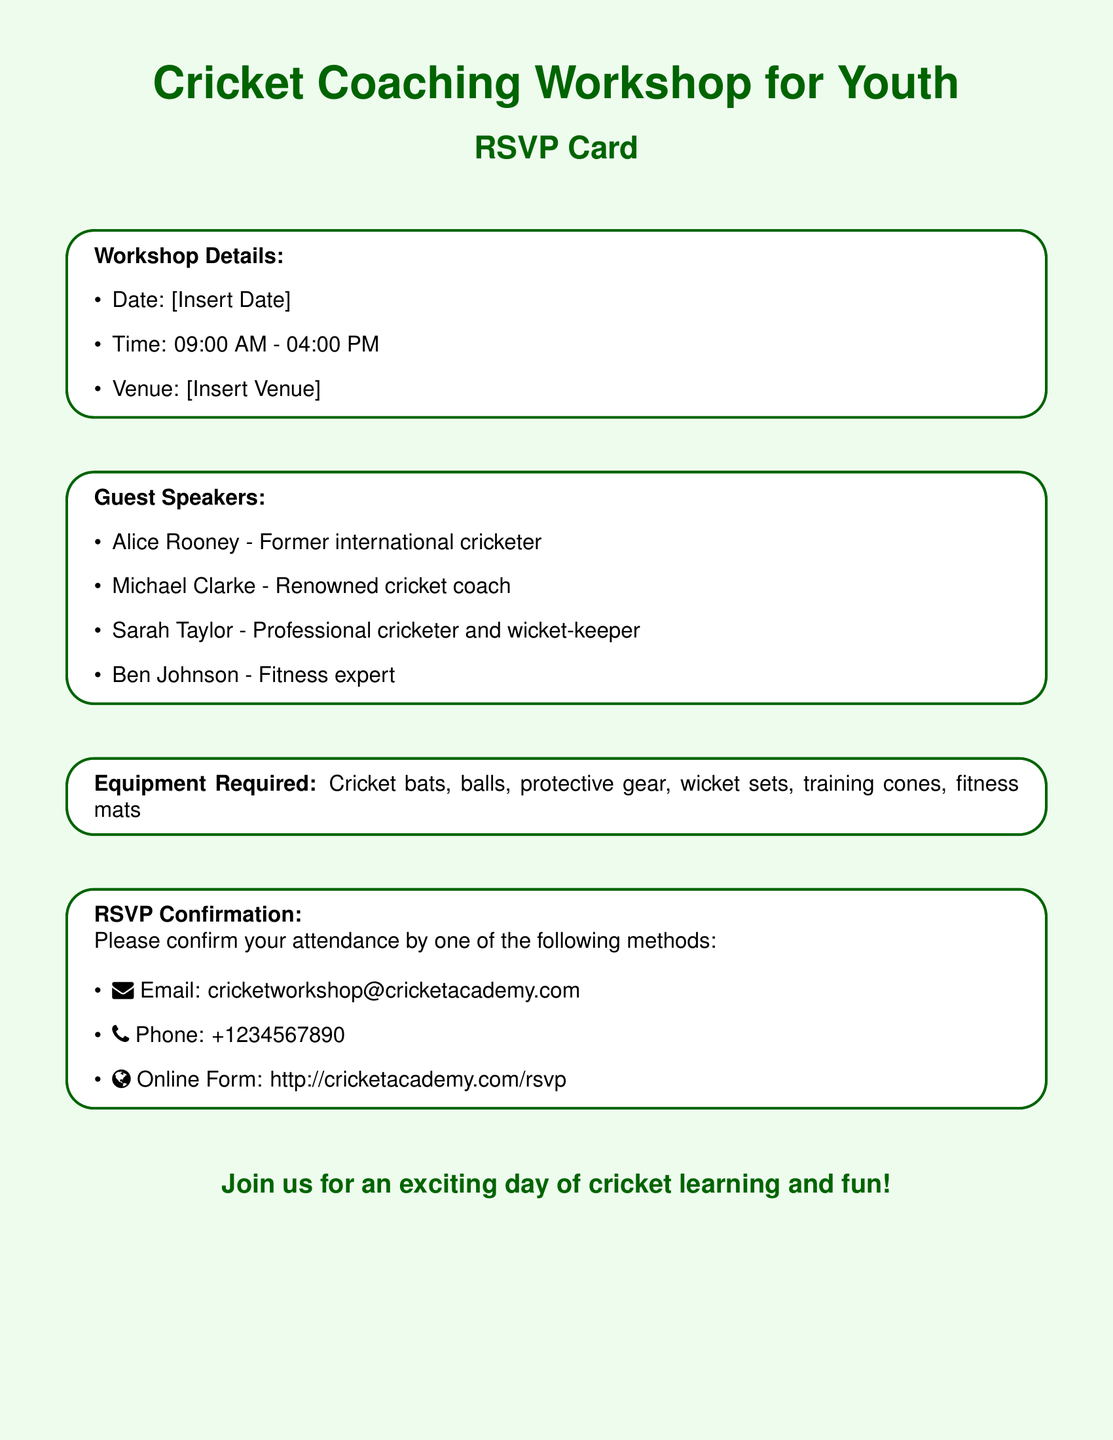What is the date of the workshop? The date of the workshop is mentioned in the document, where it states [Insert Date].
Answer: [Insert Date] What time will the workshop start? The workshop is scheduled to start at 09:00 AM, which is specified in the details section.
Answer: 09:00 AM Who is one of the guest speakers? The document lists guest speakers, and one of them is Alice Rooney.
Answer: Alice Rooney What equipment is required? The equipment required is mentioned in the document, specifically including cricket bats, balls, and protective gear.
Answer: Cricket bats, balls, protective gear, wicket sets, training cones, fitness mats How can attendees confirm their attendance? The document provides several methods for confirming attendance, such as email, phone, and an online form.
Answer: Email, Phone, Online Form Who is a renowned cricket coach speaking at the workshop? The document specifies Michael Clarke as a renowned cricket coach among the guest speakers.
Answer: Michael Clarke What is the end time of the workshop? The end time is indicated as 04:00 PM in the workshop details.
Answer: 04:00 PM What type of event is this document for? The document is specifically designed as an RSVP card for a cricket coaching workshop for youth.
Answer: Cricket Coaching Workshop for Youth 